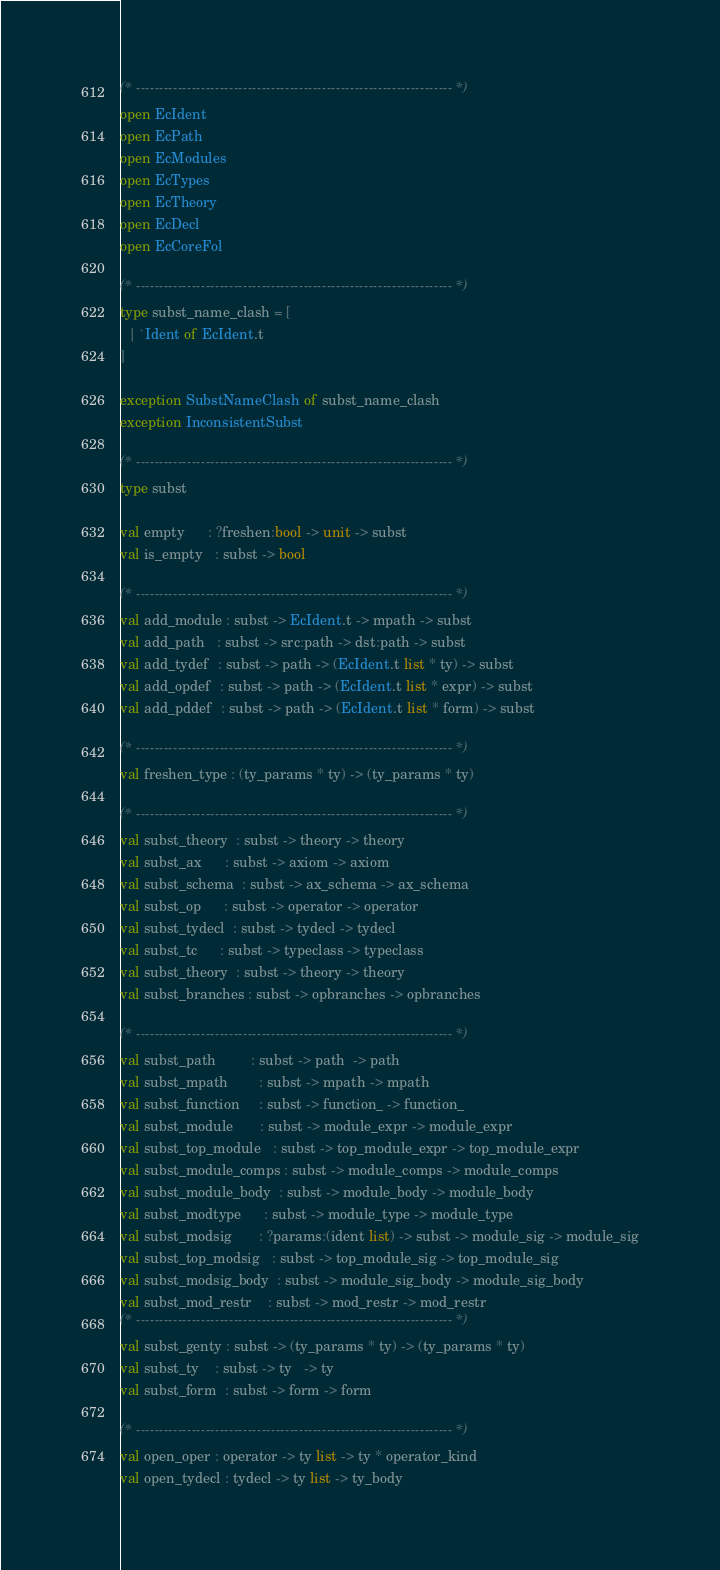Convert code to text. <code><loc_0><loc_0><loc_500><loc_500><_OCaml_>(* -------------------------------------------------------------------- *)
open EcIdent
open EcPath
open EcModules
open EcTypes
open EcTheory
open EcDecl
open EcCoreFol

(* -------------------------------------------------------------------- *)
type subst_name_clash = [
  | `Ident of EcIdent.t
]

exception SubstNameClash of subst_name_clash
exception InconsistentSubst

(* -------------------------------------------------------------------- *)
type subst

val empty      : ?freshen:bool -> unit -> subst
val is_empty   : subst -> bool

(* -------------------------------------------------------------------- *)
val add_module : subst -> EcIdent.t -> mpath -> subst
val add_path   : subst -> src:path -> dst:path -> subst
val add_tydef  : subst -> path -> (EcIdent.t list * ty) -> subst
val add_opdef  : subst -> path -> (EcIdent.t list * expr) -> subst
val add_pddef  : subst -> path -> (EcIdent.t list * form) -> subst

(* -------------------------------------------------------------------- *)
val freshen_type : (ty_params * ty) -> (ty_params * ty)

(* -------------------------------------------------------------------- *)
val subst_theory  : subst -> theory -> theory
val subst_ax      : subst -> axiom -> axiom
val subst_schema  : subst -> ax_schema -> ax_schema
val subst_op      : subst -> operator -> operator
val subst_tydecl  : subst -> tydecl -> tydecl
val subst_tc      : subst -> typeclass -> typeclass
val subst_theory  : subst -> theory -> theory
val subst_branches : subst -> opbranches -> opbranches

(* -------------------------------------------------------------------- *)
val subst_path         : subst -> path  -> path
val subst_mpath        : subst -> mpath -> mpath
val subst_function     : subst -> function_ -> function_
val subst_module       : subst -> module_expr -> module_expr
val subst_top_module   : subst -> top_module_expr -> top_module_expr
val subst_module_comps : subst -> module_comps -> module_comps
val subst_module_body  : subst -> module_body -> module_body
val subst_modtype      : subst -> module_type -> module_type
val subst_modsig       : ?params:(ident list) -> subst -> module_sig -> module_sig
val subst_top_modsig   : subst -> top_module_sig -> top_module_sig
val subst_modsig_body  : subst -> module_sig_body -> module_sig_body
val subst_mod_restr    : subst -> mod_restr -> mod_restr
(* -------------------------------------------------------------------- *)
val subst_genty : subst -> (ty_params * ty) -> (ty_params * ty)
val subst_ty    : subst -> ty   -> ty
val subst_form  : subst -> form -> form

(* -------------------------------------------------------------------- *)
val open_oper : operator -> ty list -> ty * operator_kind
val open_tydecl : tydecl -> ty list -> ty_body
</code> 